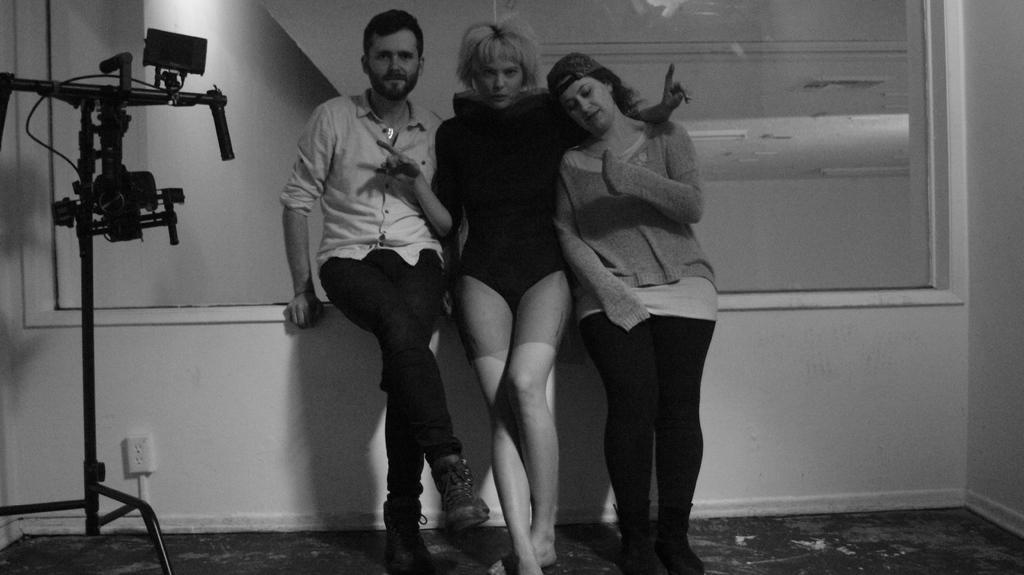How would you summarize this image in a sentence or two? This is a black and white image. In the center of the image we can see persons on the floor. In the background there is wall. 